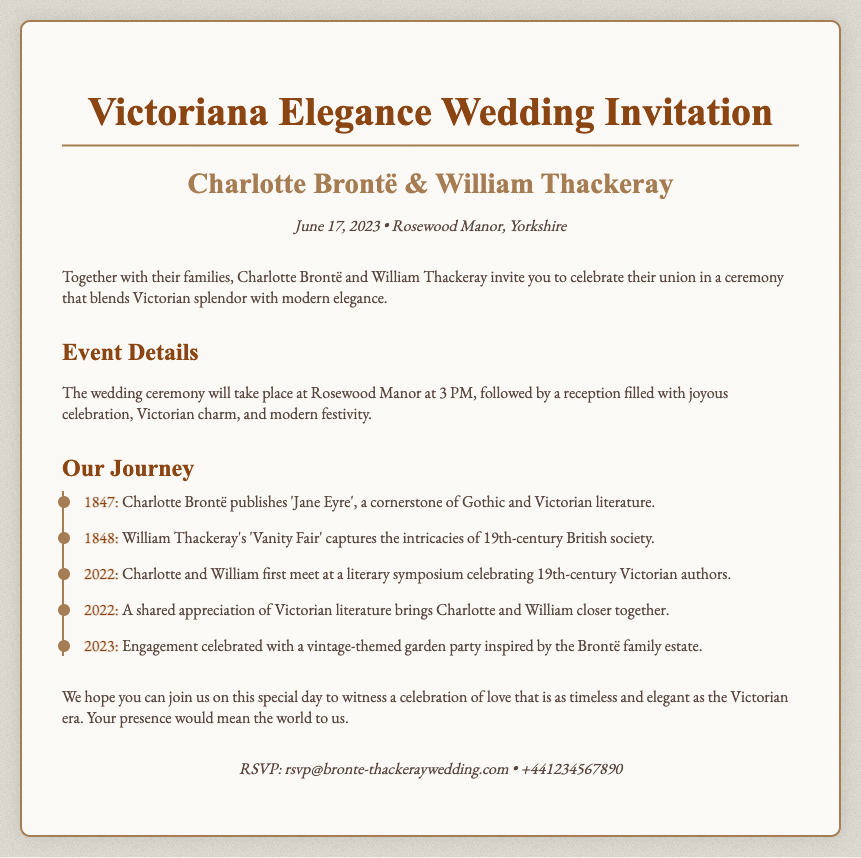What date is the wedding? The wedding date is clearly mentioned in the invitation header.
Answer: June 17, 2023 What is the venue for the wedding ceremony? The venue is provided in the invitation details.
Answer: Rosewood Manor Who are the couple getting married? The names of the couple are in the invitation header.
Answer: Charlotte Brontë & William Thackeray What time does the wedding ceremony start? The time of the ceremony is stated in the event details section.
Answer: 3 PM Which literary work did Charlotte Brontë publish in 1847? The timeline specifies the publication connected to the year.
Answer: Jane Eyre What theme inspired the engagement celebration? The engagement celebration theme is mentioned in the timeline and relates to the couple's interests.
Answer: Vintage-themed garden party What is the color scheme of the invitation's background? The background color of the invitation can be observed directly in the design.
Answer: #F8F4E9 What type of literary event did Charlotte and William first meet at? The timeline describes the nature of the event where they met.
Answer: Literary symposium What are the RSVP contact details provided? The RSVP information is listed at the end of the invitation.
Answer: rsvp@bronte-thackeraywedding.com • +441234567890 